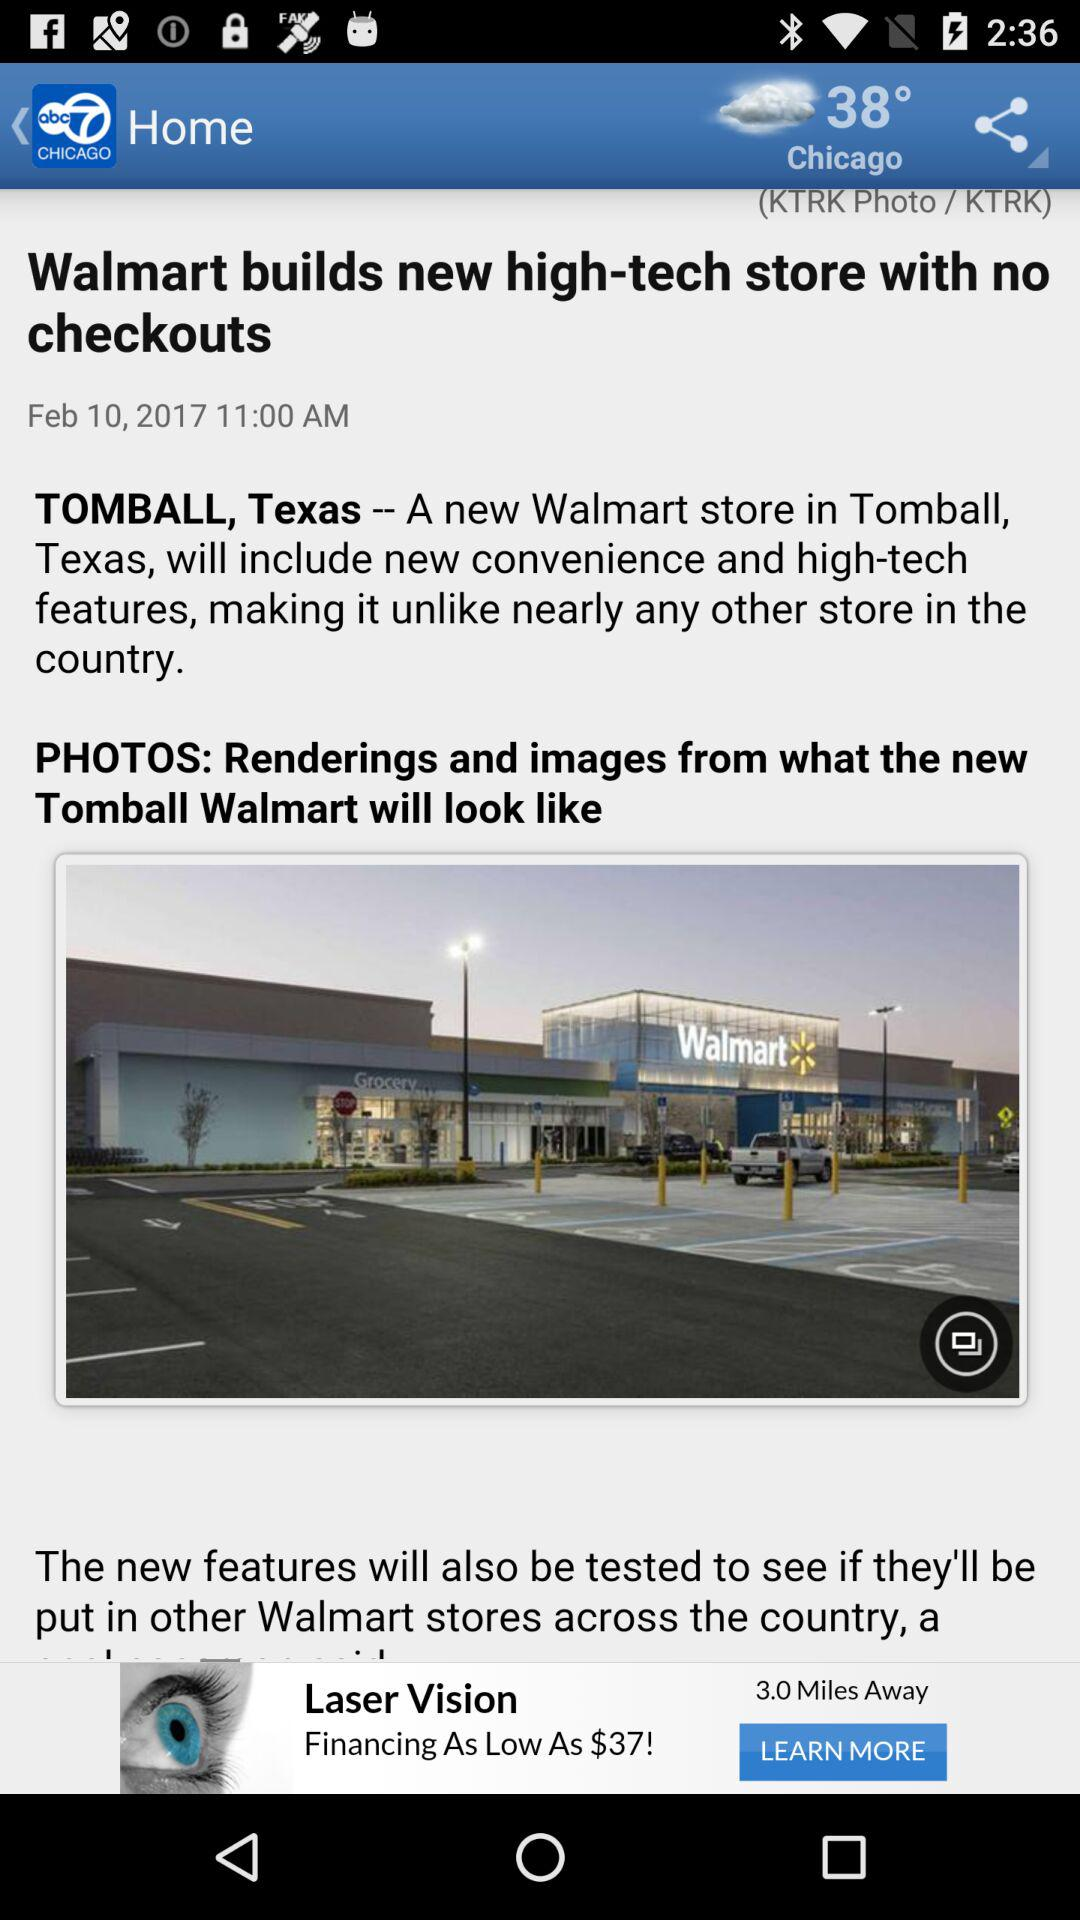What is the temperature scale?
When the provided information is insufficient, respond with <no answer>. <no answer> 